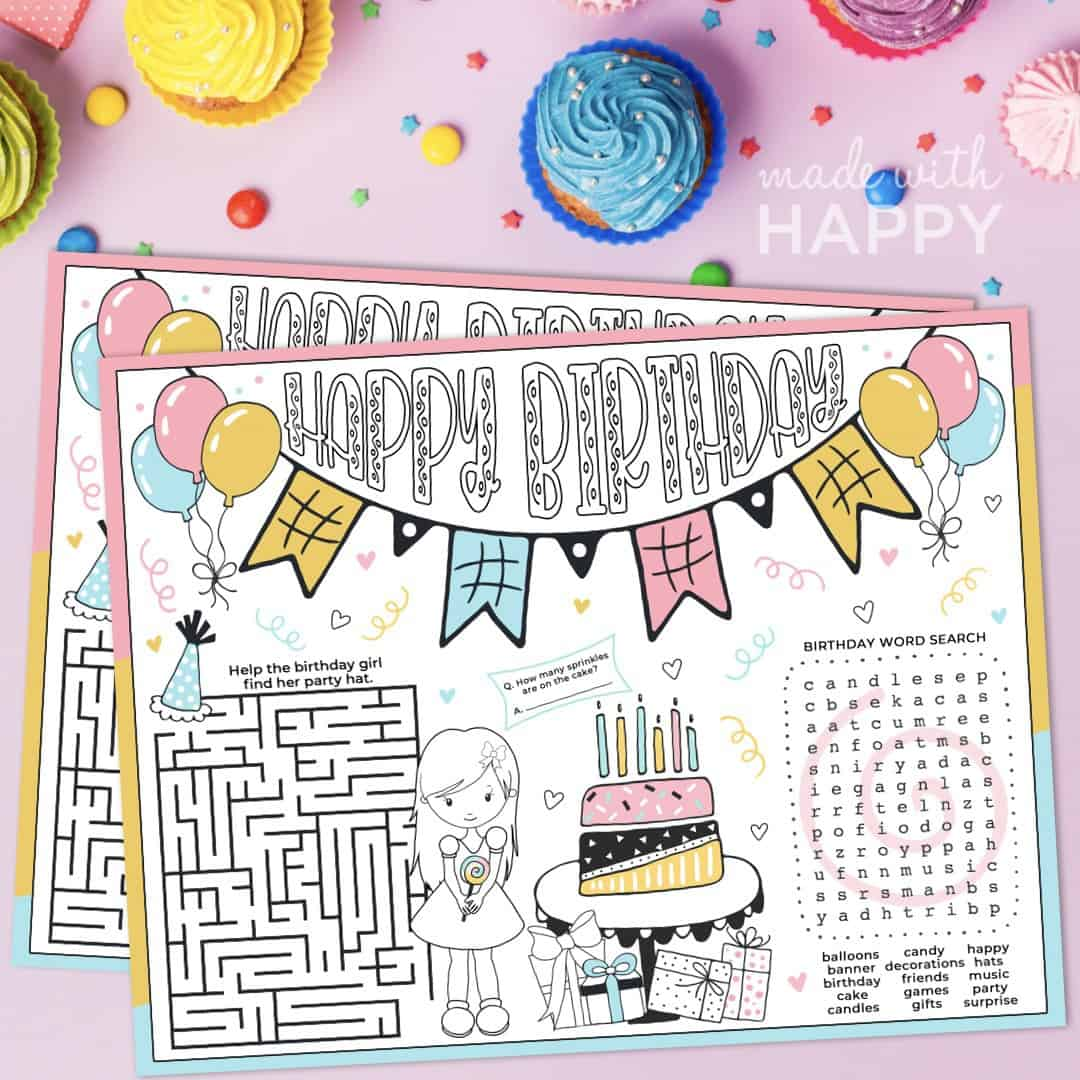What is the most colorful element in the birthday activity sheet? The most colorful elements in the birthday activity sheet are the balloons tied to the 'Happy Birthday' banner. They are rendered in yellow, pink, and blue, adding a bright and festive touch to the overall design. Can you describe a fun story involving the birthday girl and her adventure in the maze? Once upon a time, in a land filled with laughter and joy, a little girl named Lily was celebrating her birthday. Her friends had set up an enchanting birthday party, but to her surprise, they had hidden her party hat deep within a magical maze. Determined to find it, Lily embarked on an adventure through the twists and turns of the maze. Guided by colorful confetti trails and cheerfully singing balloons, she navigated through playful challenges and clever riddles. Each correct path she chose unveiled delightful gifts and sweet treats, until finally, she reached the heart of the maze, where her sparkling party hat awaited her arrival. With a triumphant giggle, she put on the hat and danced back to her friends, who cheered for her bravery and cleverness. It was a birthday Lily would never forget! 